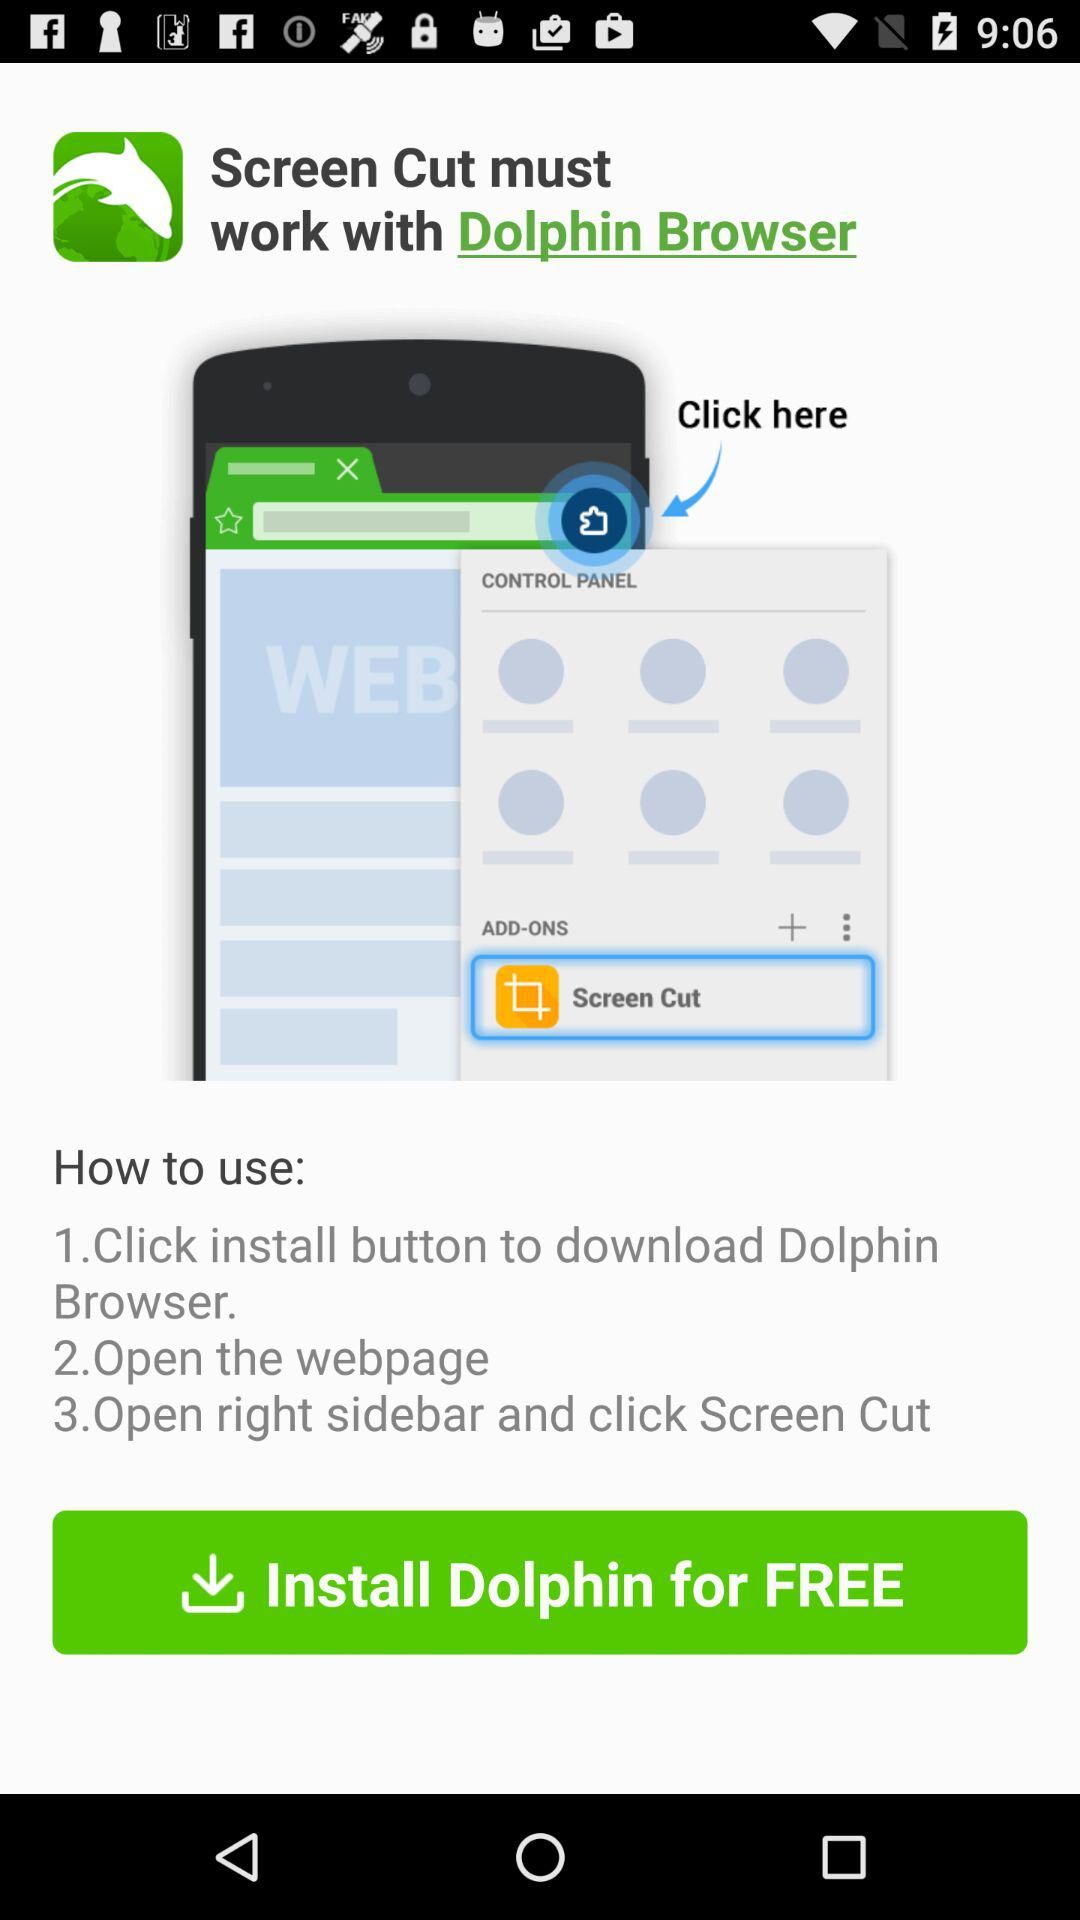What is the name of the application? The name of the application is "Dolphin Browser". 